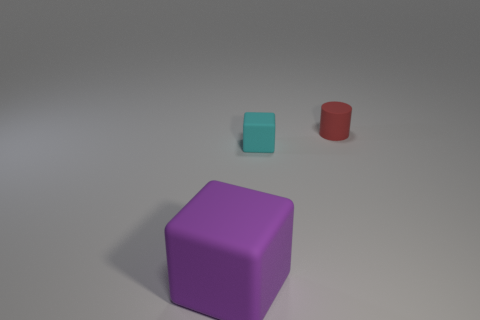Are there fewer tiny matte blocks that are on the right side of the red matte object than small red cylinders left of the big purple matte cube?
Give a very brief answer. No. Is there any other thing that has the same size as the purple object?
Offer a very short reply. No. The red thing is what shape?
Keep it short and to the point. Cylinder. What is the tiny thing that is in front of the rubber cylinder made of?
Keep it short and to the point. Rubber. There is a cube that is in front of the rubber block that is right of the rubber thing that is on the left side of the cyan rubber thing; what is its size?
Provide a succinct answer. Large. Is the block behind the big purple cube made of the same material as the block on the left side of the tiny cyan block?
Your response must be concise. Yes. How many other things are the same color as the tiny block?
Your answer should be compact. 0. How many objects are either cubes on the right side of the purple rubber object or matte objects that are on the left side of the tiny cyan cube?
Your response must be concise. 2. What is the size of the rubber block that is in front of the small matte object to the left of the cylinder?
Offer a terse response. Large. What is the size of the cyan matte cube?
Ensure brevity in your answer.  Small. 